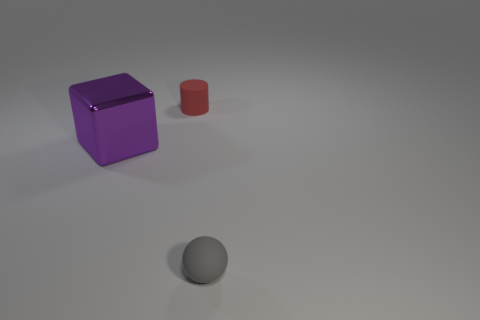Are there any other things that have the same material as the large block?
Provide a succinct answer. No. Is there a cyan block that has the same size as the red thing?
Give a very brief answer. No. How big is the rubber object that is behind the small matte object in front of the tiny thing behind the large block?
Your answer should be compact. Small. The matte ball is what color?
Provide a succinct answer. Gray. Are there more large purple blocks on the right side of the small gray rubber sphere than red matte cylinders?
Provide a succinct answer. No. There is a gray object; what number of large metallic blocks are in front of it?
Your response must be concise. 0. Are there any metallic things that are to the right of the matte thing that is behind the tiny matte object in front of the large purple metal block?
Your answer should be very brief. No. Is the size of the sphere the same as the metallic object?
Your response must be concise. No. Are there an equal number of spheres in front of the large purple thing and large purple blocks on the right side of the small gray matte object?
Provide a succinct answer. No. There is a tiny matte object that is in front of the big purple metallic block; what is its shape?
Give a very brief answer. Sphere. 